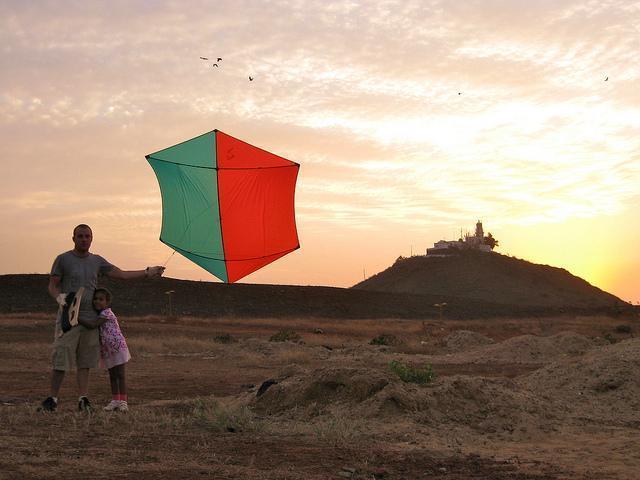How many people are there?
Give a very brief answer. 2. How many pizzas are cooked in the picture?
Give a very brief answer. 0. 